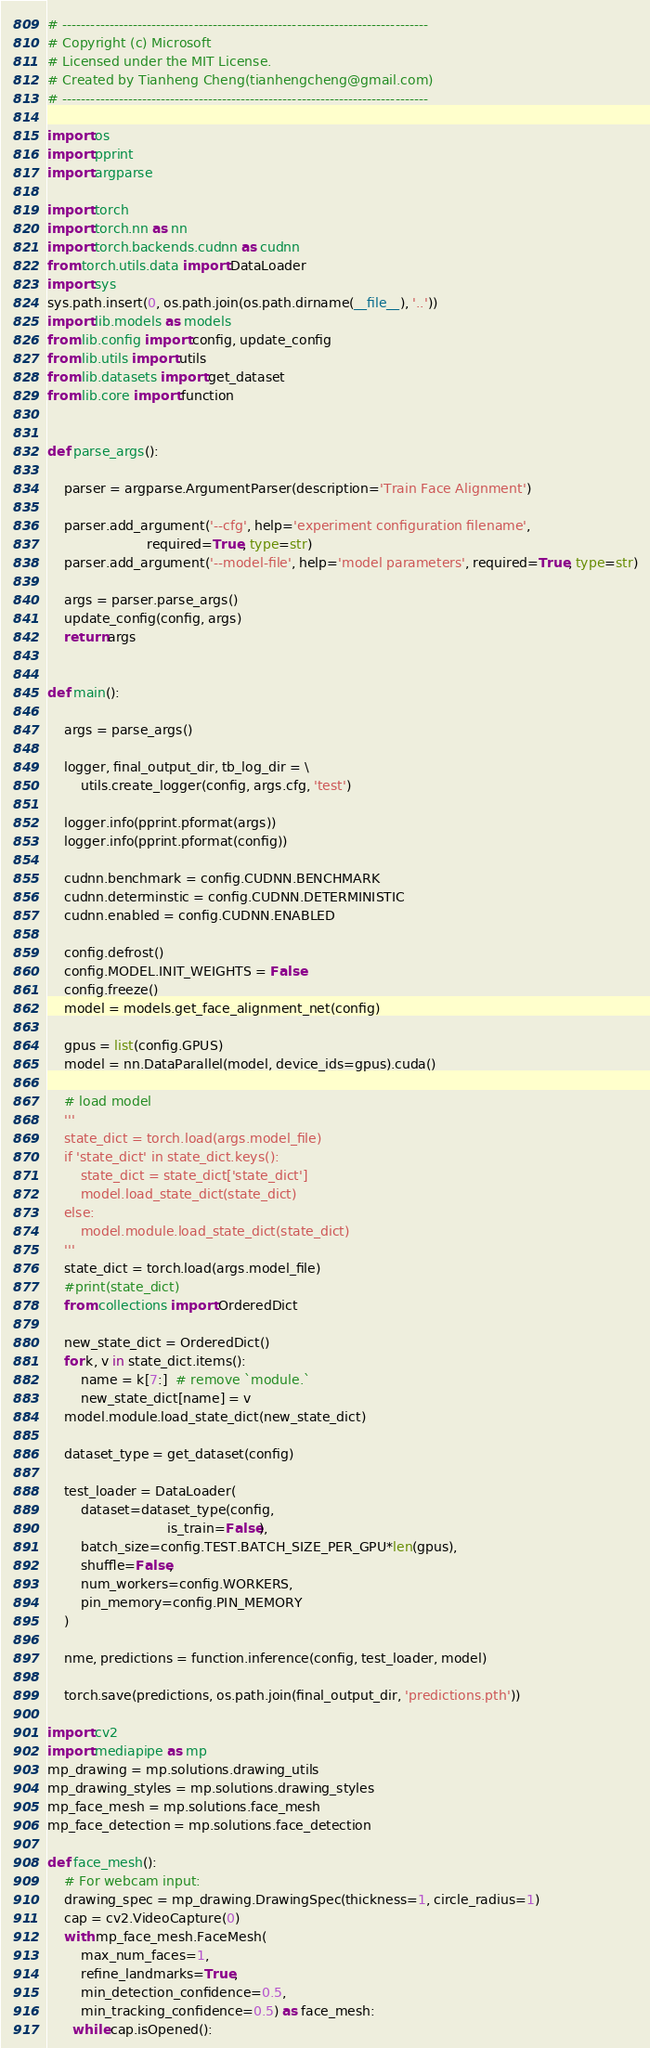Convert code to text. <code><loc_0><loc_0><loc_500><loc_500><_Python_># ------------------------------------------------------------------------------
# Copyright (c) Microsoft
# Licensed under the MIT License.
# Created by Tianheng Cheng(tianhengcheng@gmail.com)
# ------------------------------------------------------------------------------

import os
import pprint
import argparse

import torch
import torch.nn as nn
import torch.backends.cudnn as cudnn
from torch.utils.data import DataLoader
import sys
sys.path.insert(0, os.path.join(os.path.dirname(__file__), '..'))
import lib.models as models
from lib.config import config, update_config
from lib.utils import utils
from lib.datasets import get_dataset
from lib.core import function


def parse_args():

    parser = argparse.ArgumentParser(description='Train Face Alignment')

    parser.add_argument('--cfg', help='experiment configuration filename',
                        required=True, type=str)
    parser.add_argument('--model-file', help='model parameters', required=True, type=str)

    args = parser.parse_args()
    update_config(config, args)
    return args


def main():

    args = parse_args()

    logger, final_output_dir, tb_log_dir = \
        utils.create_logger(config, args.cfg, 'test')

    logger.info(pprint.pformat(args))
    logger.info(pprint.pformat(config))

    cudnn.benchmark = config.CUDNN.BENCHMARK
    cudnn.determinstic = config.CUDNN.DETERMINISTIC
    cudnn.enabled = config.CUDNN.ENABLED

    config.defrost()
    config.MODEL.INIT_WEIGHTS = False
    config.freeze()
    model = models.get_face_alignment_net(config)

    gpus = list(config.GPUS)
    model = nn.DataParallel(model, device_ids=gpus).cuda()

    # load model
    '''
    state_dict = torch.load(args.model_file)
    if 'state_dict' in state_dict.keys():
        state_dict = state_dict['state_dict']
        model.load_state_dict(state_dict)
    else:
        model.module.load_state_dict(state_dict)
    '''
    state_dict = torch.load(args.model_file)
    #print(state_dict)
    from collections import OrderedDict

    new_state_dict = OrderedDict()
    for k, v in state_dict.items():
        name = k[7:]  # remove `module.`
        new_state_dict[name] = v
    model.module.load_state_dict(new_state_dict)

    dataset_type = get_dataset(config)

    test_loader = DataLoader(
        dataset=dataset_type(config,
                             is_train=False),
        batch_size=config.TEST.BATCH_SIZE_PER_GPU*len(gpus),
        shuffle=False,
        num_workers=config.WORKERS,
        pin_memory=config.PIN_MEMORY
    )

    nme, predictions = function.inference(config, test_loader, model)

    torch.save(predictions, os.path.join(final_output_dir, 'predictions.pth'))

import cv2
import mediapipe as mp
mp_drawing = mp.solutions.drawing_utils
mp_drawing_styles = mp.solutions.drawing_styles
mp_face_mesh = mp.solutions.face_mesh
mp_face_detection = mp.solutions.face_detection

def face_mesh():
    # For webcam input:
    drawing_spec = mp_drawing.DrawingSpec(thickness=1, circle_radius=1)
    cap = cv2.VideoCapture(0)
    with mp_face_mesh.FaceMesh(
        max_num_faces=1,
        refine_landmarks=True,
        min_detection_confidence=0.5,
        min_tracking_confidence=0.5) as face_mesh:
      while cap.isOpened():</code> 